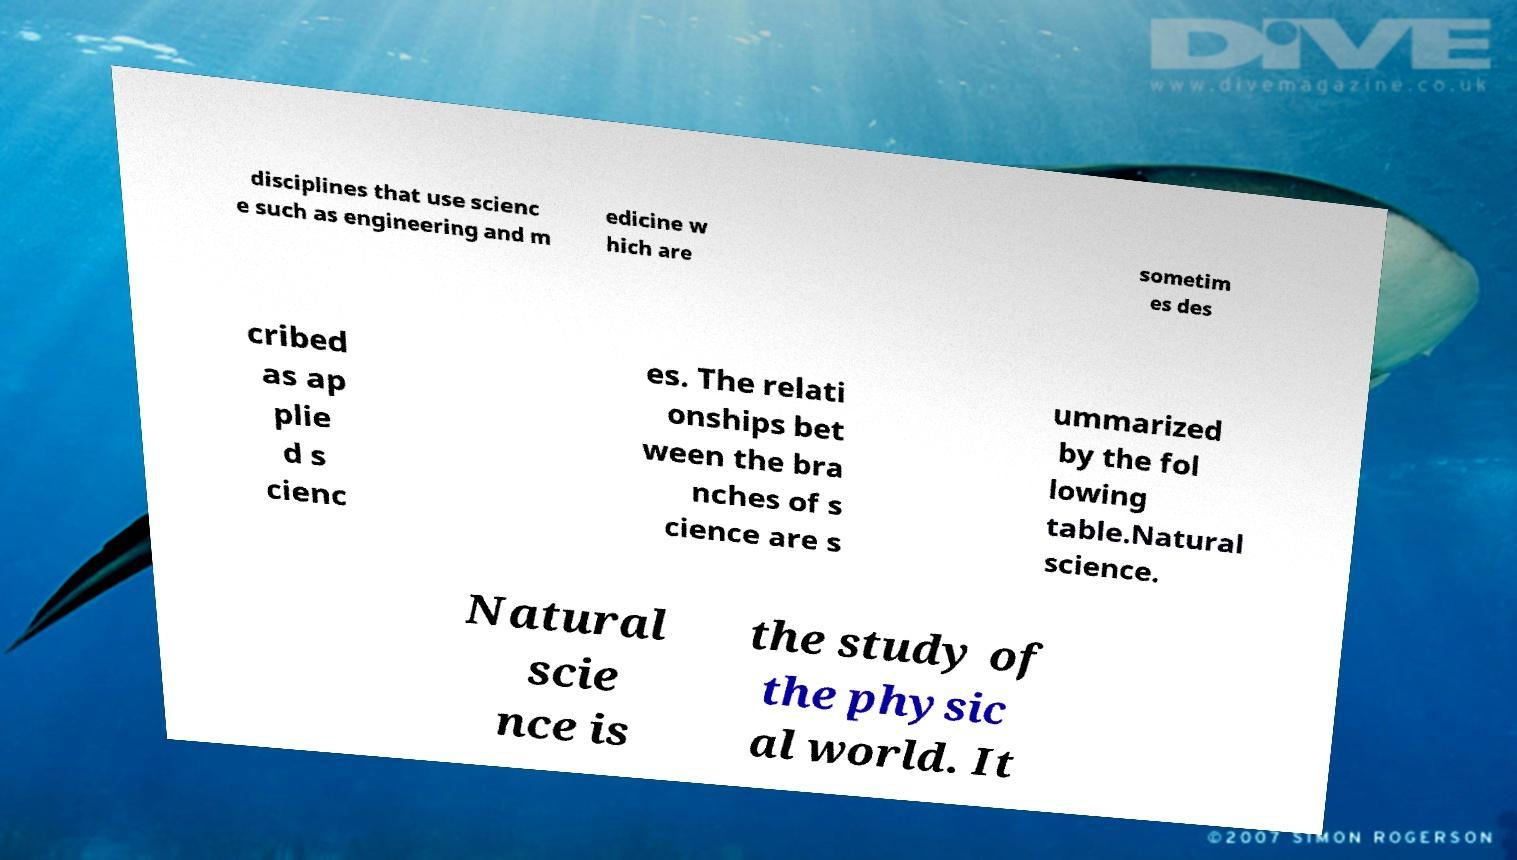Could you extract and type out the text from this image? disciplines that use scienc e such as engineering and m edicine w hich are sometim es des cribed as ap plie d s cienc es. The relati onships bet ween the bra nches of s cience are s ummarized by the fol lowing table.Natural science. Natural scie nce is the study of the physic al world. It 